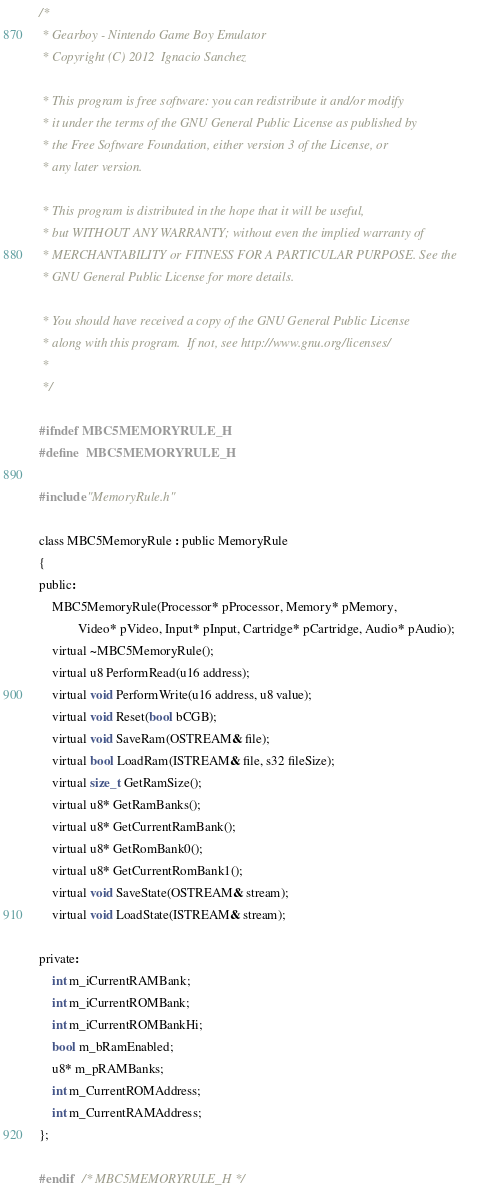Convert code to text. <code><loc_0><loc_0><loc_500><loc_500><_C_>/*
 * Gearboy - Nintendo Game Boy Emulator
 * Copyright (C) 2012  Ignacio Sanchez

 * This program is free software: you can redistribute it and/or modify
 * it under the terms of the GNU General Public License as published by
 * the Free Software Foundation, either version 3 of the License, or
 * any later version.

 * This program is distributed in the hope that it will be useful,
 * but WITHOUT ANY WARRANTY; without even the implied warranty of
 * MERCHANTABILITY or FITNESS FOR A PARTICULAR PURPOSE. See the
 * GNU General Public License for more details.

 * You should have received a copy of the GNU General Public License
 * along with this program.  If not, see http://www.gnu.org/licenses/
 *
 */

#ifndef MBC5MEMORYRULE_H
#define	MBC5MEMORYRULE_H

#include "MemoryRule.h"

class MBC5MemoryRule : public MemoryRule
{
public:
    MBC5MemoryRule(Processor* pProcessor, Memory* pMemory,
            Video* pVideo, Input* pInput, Cartridge* pCartridge, Audio* pAudio);
    virtual ~MBC5MemoryRule();
    virtual u8 PerformRead(u16 address);
    virtual void PerformWrite(u16 address, u8 value);
    virtual void Reset(bool bCGB);
    virtual void SaveRam(OSTREAM& file);
    virtual bool LoadRam(ISTREAM& file, s32 fileSize);
    virtual size_t GetRamSize();
    virtual u8* GetRamBanks();
    virtual u8* GetCurrentRamBank();
    virtual u8* GetRomBank0();
    virtual u8* GetCurrentRomBank1();
    virtual void SaveState(OSTREAM& stream);
    virtual void LoadState(ISTREAM& stream);

private:
    int m_iCurrentRAMBank;
    int m_iCurrentROMBank;
    int m_iCurrentROMBankHi;
    bool m_bRamEnabled;
    u8* m_pRAMBanks;
    int m_CurrentROMAddress;
    int m_CurrentRAMAddress;
};

#endif	/* MBC5MEMORYRULE_H */
</code> 